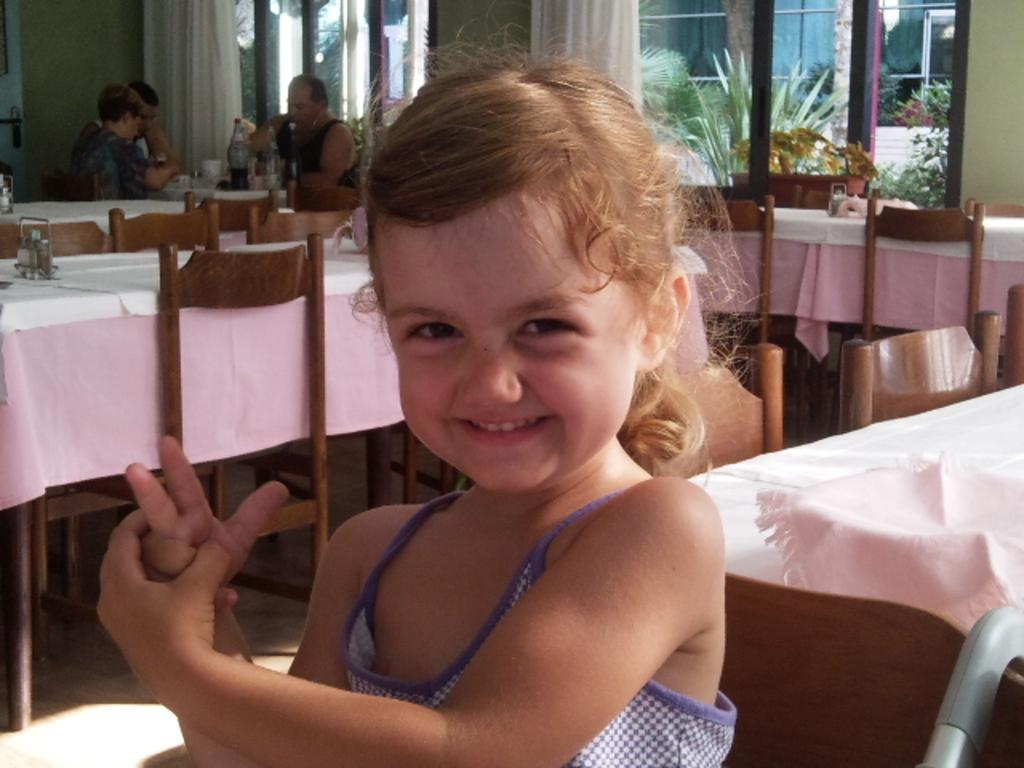What is the main subject of the image? There is a child in the image. What is the child doing in the image? The child is sitting and smiling. What can be seen in the background of the image? There are chairs, tables, persons sitting, glass windows, and trees visible through the glass windows. How many eyes does the carpenter have in the image? There is no carpenter present in the image. 